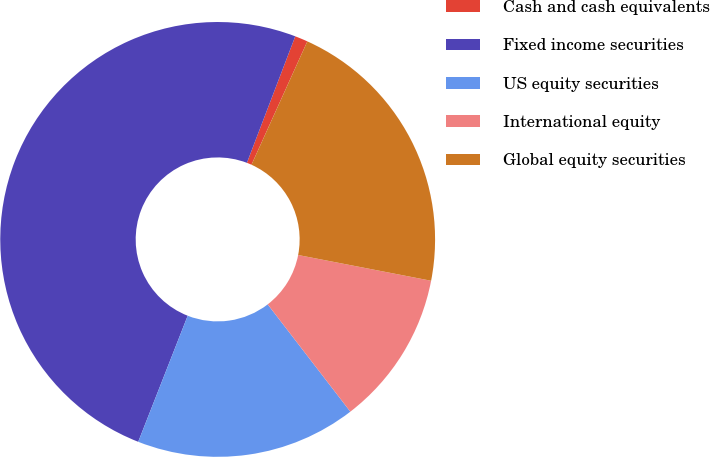<chart> <loc_0><loc_0><loc_500><loc_500><pie_chart><fcel>Cash and cash equivalents<fcel>Fixed income securities<fcel>US equity securities<fcel>International equity<fcel>Global equity securities<nl><fcel>0.96%<fcel>49.86%<fcel>16.4%<fcel>11.51%<fcel>21.28%<nl></chart> 